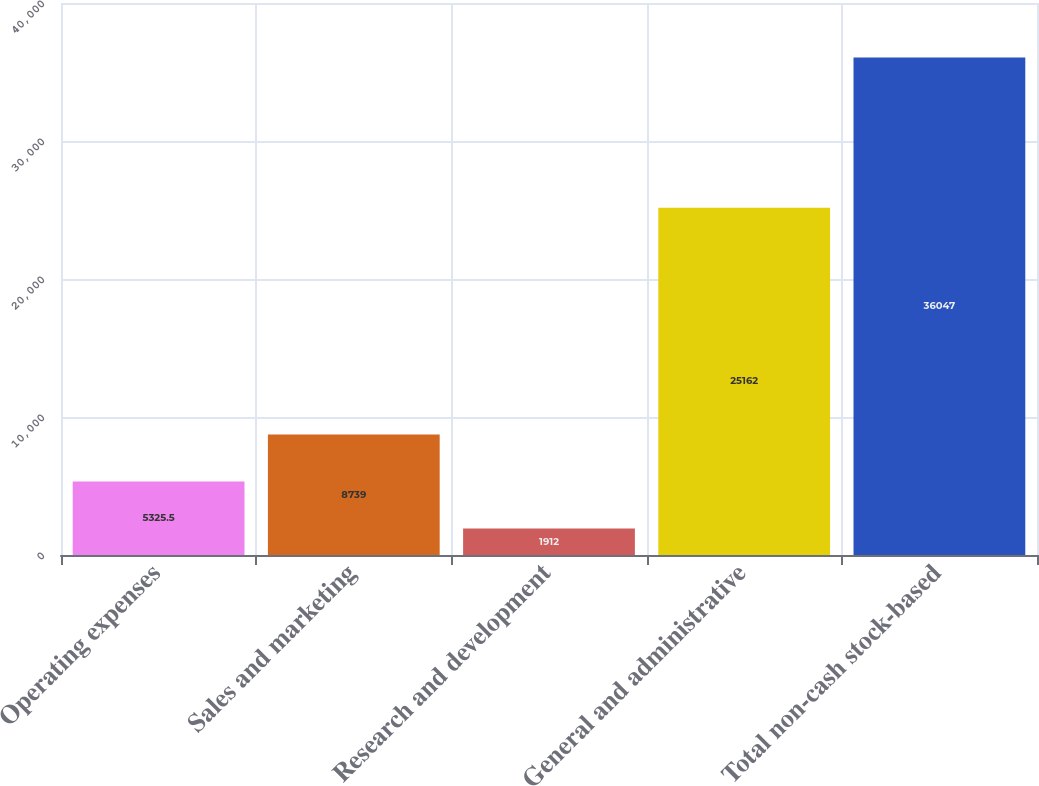Convert chart to OTSL. <chart><loc_0><loc_0><loc_500><loc_500><bar_chart><fcel>Operating expenses<fcel>Sales and marketing<fcel>Research and development<fcel>General and administrative<fcel>Total non-cash stock-based<nl><fcel>5325.5<fcel>8739<fcel>1912<fcel>25162<fcel>36047<nl></chart> 